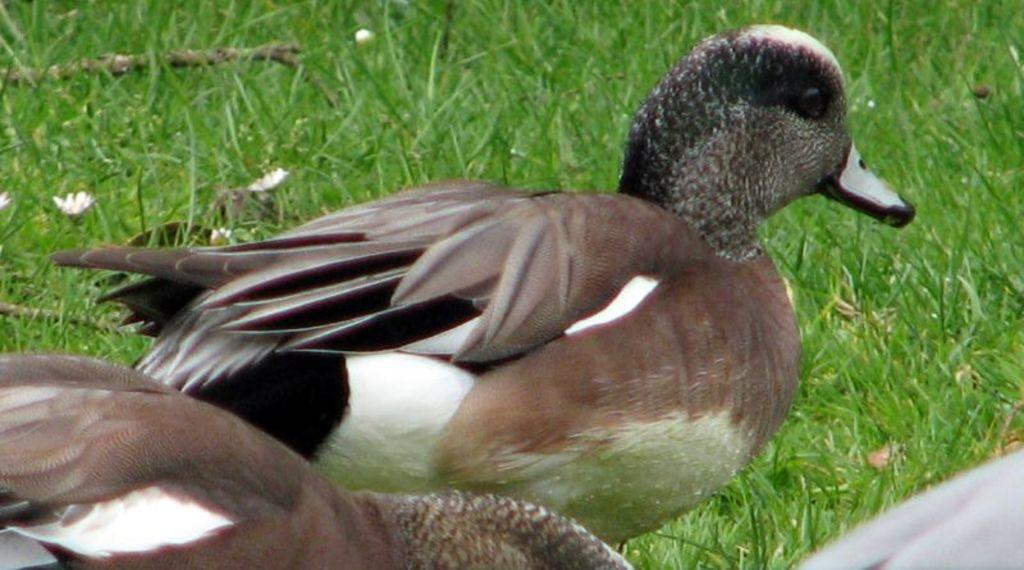What type of animals are present in the image? There are ducks in the image. What other elements can be seen in the image besides the ducks? There are flowers and grass in the image. What type of mass can be seen in the image? There is no mass present in the image; it features ducks, flowers, and grass. Is there a can visible in the image? There is no can present in the image. 